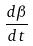<formula> <loc_0><loc_0><loc_500><loc_500>\frac { d \beta } { d t }</formula> 